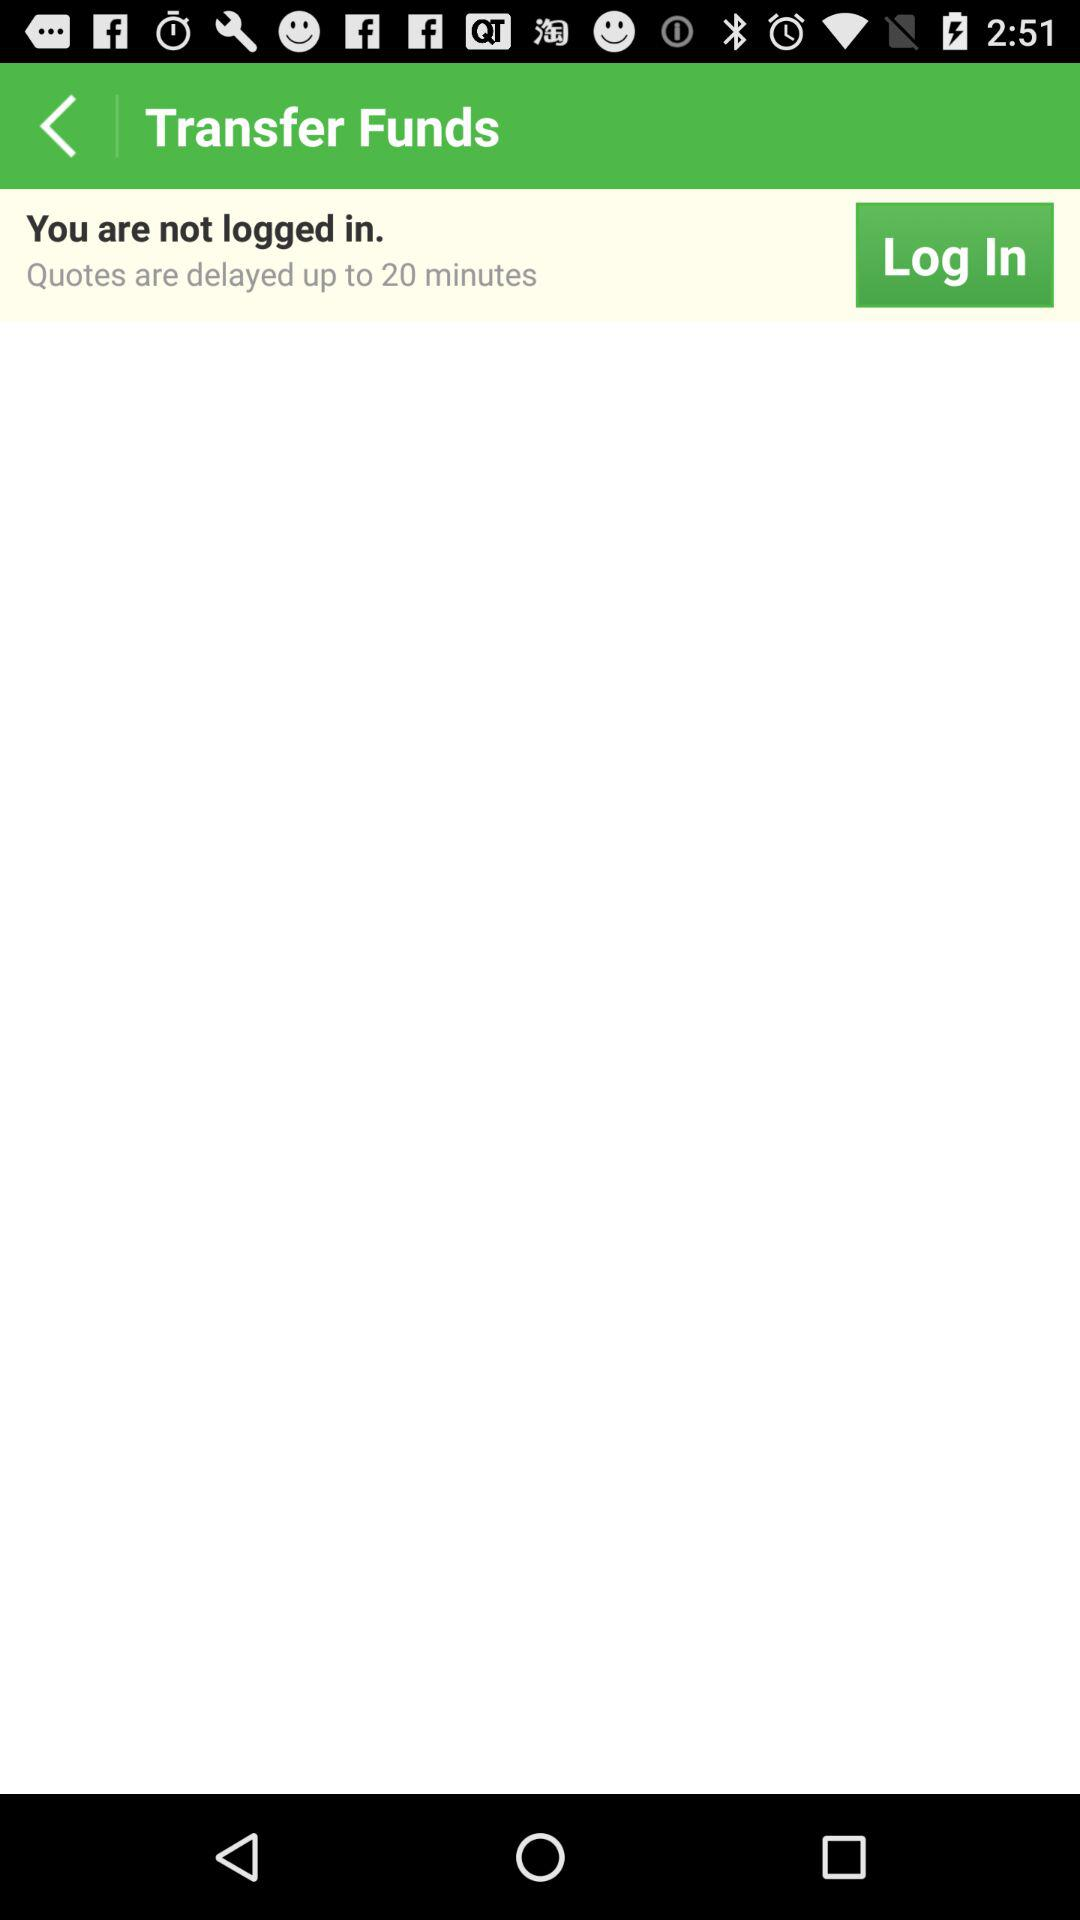How long are the quotes delayed? The quotes are delayed up to 20 minutes. 